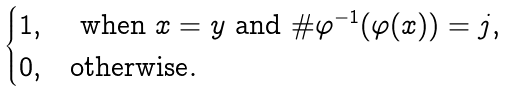Convert formula to latex. <formula><loc_0><loc_0><loc_500><loc_500>\begin{cases} 1 , & \ \text {when $x=y$ and $\#   \varphi^{-1}(\varphi(x)) = j$} , \\ 0 , & \text {otherwise} . \end{cases}</formula> 